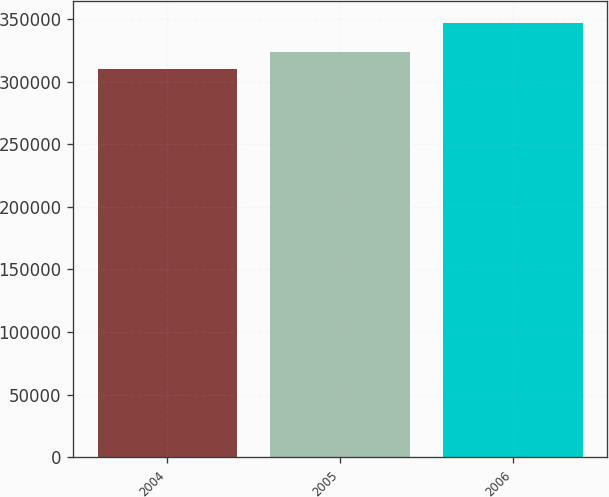<chart> <loc_0><loc_0><loc_500><loc_500><bar_chart><fcel>2004<fcel>2005<fcel>2006<nl><fcel>310368<fcel>324024<fcel>347051<nl></chart> 